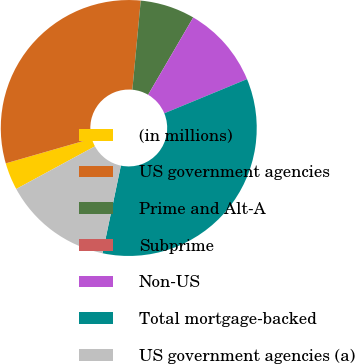Convert chart. <chart><loc_0><loc_0><loc_500><loc_500><pie_chart><fcel>(in millions)<fcel>US government agencies<fcel>Prime and Alt-A<fcel>Subprime<fcel>Non-US<fcel>Total mortgage-backed<fcel>US government agencies (a)<nl><fcel>3.45%<fcel>30.95%<fcel>6.91%<fcel>0.0%<fcel>10.36%<fcel>34.52%<fcel>13.81%<nl></chart> 